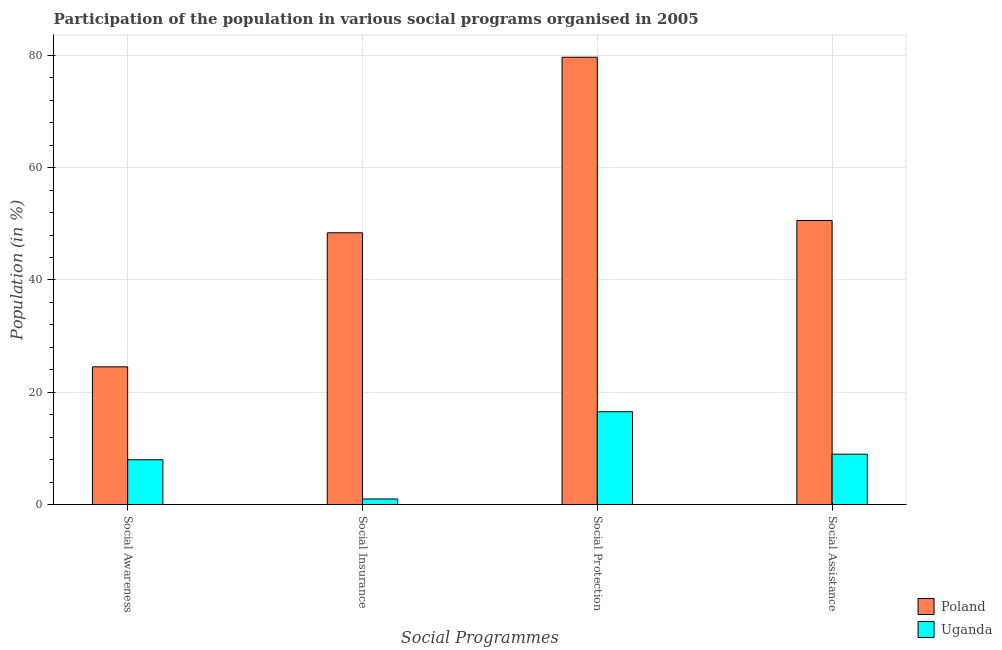Are the number of bars on each tick of the X-axis equal?
Offer a terse response. Yes. How many bars are there on the 1st tick from the left?
Ensure brevity in your answer.  2. How many bars are there on the 3rd tick from the right?
Offer a terse response. 2. What is the label of the 3rd group of bars from the left?
Keep it short and to the point. Social Protection. What is the participation of population in social protection programs in Uganda?
Offer a very short reply. 16.53. Across all countries, what is the maximum participation of population in social awareness programs?
Provide a short and direct response. 24.53. Across all countries, what is the minimum participation of population in social awareness programs?
Offer a very short reply. 7.98. In which country was the participation of population in social assistance programs maximum?
Keep it short and to the point. Poland. In which country was the participation of population in social awareness programs minimum?
Ensure brevity in your answer.  Uganda. What is the total participation of population in social insurance programs in the graph?
Your answer should be very brief. 49.39. What is the difference between the participation of population in social assistance programs in Poland and that in Uganda?
Keep it short and to the point. 41.62. What is the difference between the participation of population in social assistance programs in Poland and the participation of population in social protection programs in Uganda?
Provide a succinct answer. 34.05. What is the average participation of population in social insurance programs per country?
Provide a short and direct response. 24.69. What is the difference between the participation of population in social insurance programs and participation of population in social awareness programs in Poland?
Give a very brief answer. 23.87. What is the ratio of the participation of population in social insurance programs in Poland to that in Uganda?
Give a very brief answer. 48.82. Is the participation of population in social insurance programs in Poland less than that in Uganda?
Keep it short and to the point. No. What is the difference between the highest and the second highest participation of population in social protection programs?
Give a very brief answer. 63.13. What is the difference between the highest and the lowest participation of population in social protection programs?
Your response must be concise. 63.13. In how many countries, is the participation of population in social protection programs greater than the average participation of population in social protection programs taken over all countries?
Provide a short and direct response. 1. Is the sum of the participation of population in social insurance programs in Uganda and Poland greater than the maximum participation of population in social awareness programs across all countries?
Your answer should be very brief. Yes. Is it the case that in every country, the sum of the participation of population in social insurance programs and participation of population in social protection programs is greater than the sum of participation of population in social assistance programs and participation of population in social awareness programs?
Your answer should be very brief. No. What does the 1st bar from the left in Social Awareness represents?
Keep it short and to the point. Poland. What does the 1st bar from the right in Social Awareness represents?
Ensure brevity in your answer.  Uganda. Is it the case that in every country, the sum of the participation of population in social awareness programs and participation of population in social insurance programs is greater than the participation of population in social protection programs?
Ensure brevity in your answer.  No. How many bars are there?
Provide a short and direct response. 8. Are all the bars in the graph horizontal?
Keep it short and to the point. No. Are the values on the major ticks of Y-axis written in scientific E-notation?
Offer a very short reply. No. Does the graph contain any zero values?
Your response must be concise. No. Where does the legend appear in the graph?
Offer a very short reply. Bottom right. How are the legend labels stacked?
Your answer should be very brief. Vertical. What is the title of the graph?
Your response must be concise. Participation of the population in various social programs organised in 2005. Does "Canada" appear as one of the legend labels in the graph?
Give a very brief answer. No. What is the label or title of the X-axis?
Give a very brief answer. Social Programmes. What is the label or title of the Y-axis?
Your answer should be compact. Population (in %). What is the Population (in %) in Poland in Social Awareness?
Give a very brief answer. 24.53. What is the Population (in %) of Uganda in Social Awareness?
Your response must be concise. 7.98. What is the Population (in %) of Poland in Social Insurance?
Provide a succinct answer. 48.4. What is the Population (in %) of Uganda in Social Insurance?
Ensure brevity in your answer.  0.99. What is the Population (in %) in Poland in Social Protection?
Make the answer very short. 79.66. What is the Population (in %) of Uganda in Social Protection?
Your response must be concise. 16.53. What is the Population (in %) of Poland in Social Assistance?
Ensure brevity in your answer.  50.58. What is the Population (in %) in Uganda in Social Assistance?
Offer a terse response. 8.97. Across all Social Programmes, what is the maximum Population (in %) in Poland?
Offer a very short reply. 79.66. Across all Social Programmes, what is the maximum Population (in %) of Uganda?
Give a very brief answer. 16.53. Across all Social Programmes, what is the minimum Population (in %) in Poland?
Provide a succinct answer. 24.53. Across all Social Programmes, what is the minimum Population (in %) in Uganda?
Ensure brevity in your answer.  0.99. What is the total Population (in %) in Poland in the graph?
Offer a terse response. 203.17. What is the total Population (in %) in Uganda in the graph?
Your answer should be very brief. 34.46. What is the difference between the Population (in %) of Poland in Social Awareness and that in Social Insurance?
Offer a very short reply. -23.87. What is the difference between the Population (in %) of Uganda in Social Awareness and that in Social Insurance?
Your answer should be compact. 6.99. What is the difference between the Population (in %) of Poland in Social Awareness and that in Social Protection?
Make the answer very short. -55.13. What is the difference between the Population (in %) in Uganda in Social Awareness and that in Social Protection?
Your response must be concise. -8.55. What is the difference between the Population (in %) of Poland in Social Awareness and that in Social Assistance?
Offer a terse response. -26.06. What is the difference between the Population (in %) of Uganda in Social Awareness and that in Social Assistance?
Your response must be concise. -0.99. What is the difference between the Population (in %) of Poland in Social Insurance and that in Social Protection?
Provide a short and direct response. -31.26. What is the difference between the Population (in %) of Uganda in Social Insurance and that in Social Protection?
Provide a succinct answer. -15.54. What is the difference between the Population (in %) in Poland in Social Insurance and that in Social Assistance?
Give a very brief answer. -2.18. What is the difference between the Population (in %) of Uganda in Social Insurance and that in Social Assistance?
Provide a short and direct response. -7.98. What is the difference between the Population (in %) in Poland in Social Protection and that in Social Assistance?
Offer a very short reply. 29.08. What is the difference between the Population (in %) of Uganda in Social Protection and that in Social Assistance?
Offer a terse response. 7.56. What is the difference between the Population (in %) of Poland in Social Awareness and the Population (in %) of Uganda in Social Insurance?
Ensure brevity in your answer.  23.54. What is the difference between the Population (in %) in Poland in Social Awareness and the Population (in %) in Uganda in Social Protection?
Provide a short and direct response. 8. What is the difference between the Population (in %) of Poland in Social Awareness and the Population (in %) of Uganda in Social Assistance?
Offer a terse response. 15.56. What is the difference between the Population (in %) of Poland in Social Insurance and the Population (in %) of Uganda in Social Protection?
Provide a short and direct response. 31.87. What is the difference between the Population (in %) of Poland in Social Insurance and the Population (in %) of Uganda in Social Assistance?
Make the answer very short. 39.43. What is the difference between the Population (in %) of Poland in Social Protection and the Population (in %) of Uganda in Social Assistance?
Your response must be concise. 70.69. What is the average Population (in %) of Poland per Social Programmes?
Offer a terse response. 50.79. What is the average Population (in %) in Uganda per Social Programmes?
Offer a terse response. 8.62. What is the difference between the Population (in %) of Poland and Population (in %) of Uganda in Social Awareness?
Offer a very short reply. 16.55. What is the difference between the Population (in %) of Poland and Population (in %) of Uganda in Social Insurance?
Your answer should be very brief. 47.41. What is the difference between the Population (in %) of Poland and Population (in %) of Uganda in Social Protection?
Provide a succinct answer. 63.13. What is the difference between the Population (in %) of Poland and Population (in %) of Uganda in Social Assistance?
Offer a very short reply. 41.62. What is the ratio of the Population (in %) in Poland in Social Awareness to that in Social Insurance?
Your response must be concise. 0.51. What is the ratio of the Population (in %) of Uganda in Social Awareness to that in Social Insurance?
Offer a terse response. 8.05. What is the ratio of the Population (in %) of Poland in Social Awareness to that in Social Protection?
Give a very brief answer. 0.31. What is the ratio of the Population (in %) of Uganda in Social Awareness to that in Social Protection?
Ensure brevity in your answer.  0.48. What is the ratio of the Population (in %) in Poland in Social Awareness to that in Social Assistance?
Ensure brevity in your answer.  0.48. What is the ratio of the Population (in %) of Uganda in Social Awareness to that in Social Assistance?
Ensure brevity in your answer.  0.89. What is the ratio of the Population (in %) in Poland in Social Insurance to that in Social Protection?
Your answer should be very brief. 0.61. What is the ratio of the Population (in %) of Uganda in Social Insurance to that in Social Protection?
Provide a short and direct response. 0.06. What is the ratio of the Population (in %) of Poland in Social Insurance to that in Social Assistance?
Your answer should be compact. 0.96. What is the ratio of the Population (in %) in Uganda in Social Insurance to that in Social Assistance?
Ensure brevity in your answer.  0.11. What is the ratio of the Population (in %) in Poland in Social Protection to that in Social Assistance?
Give a very brief answer. 1.57. What is the ratio of the Population (in %) of Uganda in Social Protection to that in Social Assistance?
Ensure brevity in your answer.  1.84. What is the difference between the highest and the second highest Population (in %) of Poland?
Offer a very short reply. 29.08. What is the difference between the highest and the second highest Population (in %) of Uganda?
Provide a short and direct response. 7.56. What is the difference between the highest and the lowest Population (in %) of Poland?
Provide a succinct answer. 55.13. What is the difference between the highest and the lowest Population (in %) of Uganda?
Your response must be concise. 15.54. 